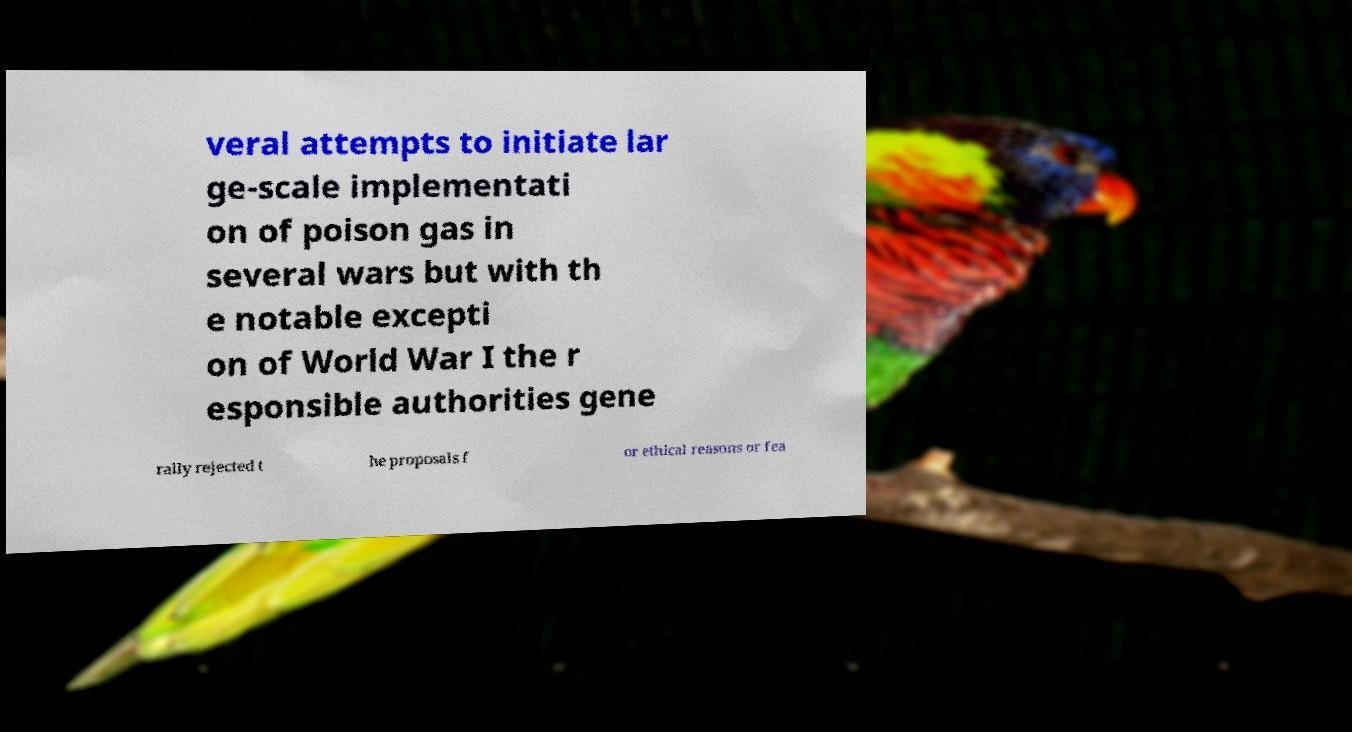There's text embedded in this image that I need extracted. Can you transcribe it verbatim? veral attempts to initiate lar ge-scale implementati on of poison gas in several wars but with th e notable excepti on of World War I the r esponsible authorities gene rally rejected t he proposals f or ethical reasons or fea 